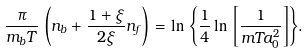<formula> <loc_0><loc_0><loc_500><loc_500>\frac { \pi } { m _ { b } T } \, \left ( n _ { b } + \frac { 1 + \xi } { 2 \xi } n _ { f } \right ) \, = \ln { \, \left \{ \frac { 1 } { 4 } \ln { \, \left [ \frac { 1 } { m T a _ { 0 } ^ { 2 } } \right ] } \right \} } .</formula> 